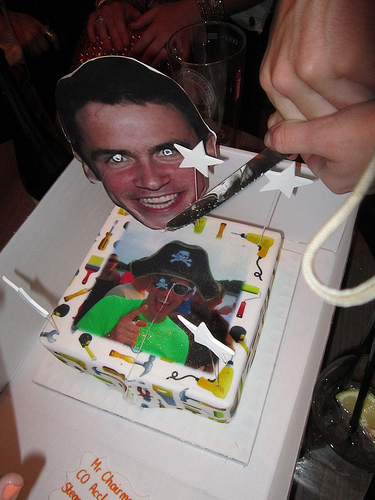What is the overall theme or occasion represented in the image? The image depicts a celebration cake, which, judging by the eclectic mix of decorations and personal images, suggests a jovial and possibly humorous event, such as a birthday party with a personalized touch. Describe the person depicted on the cake. The person on the cake appears in pirate attire, complete with a hat and eye patch, which seems to playfully allude to a lighthearted or themed celebration. 